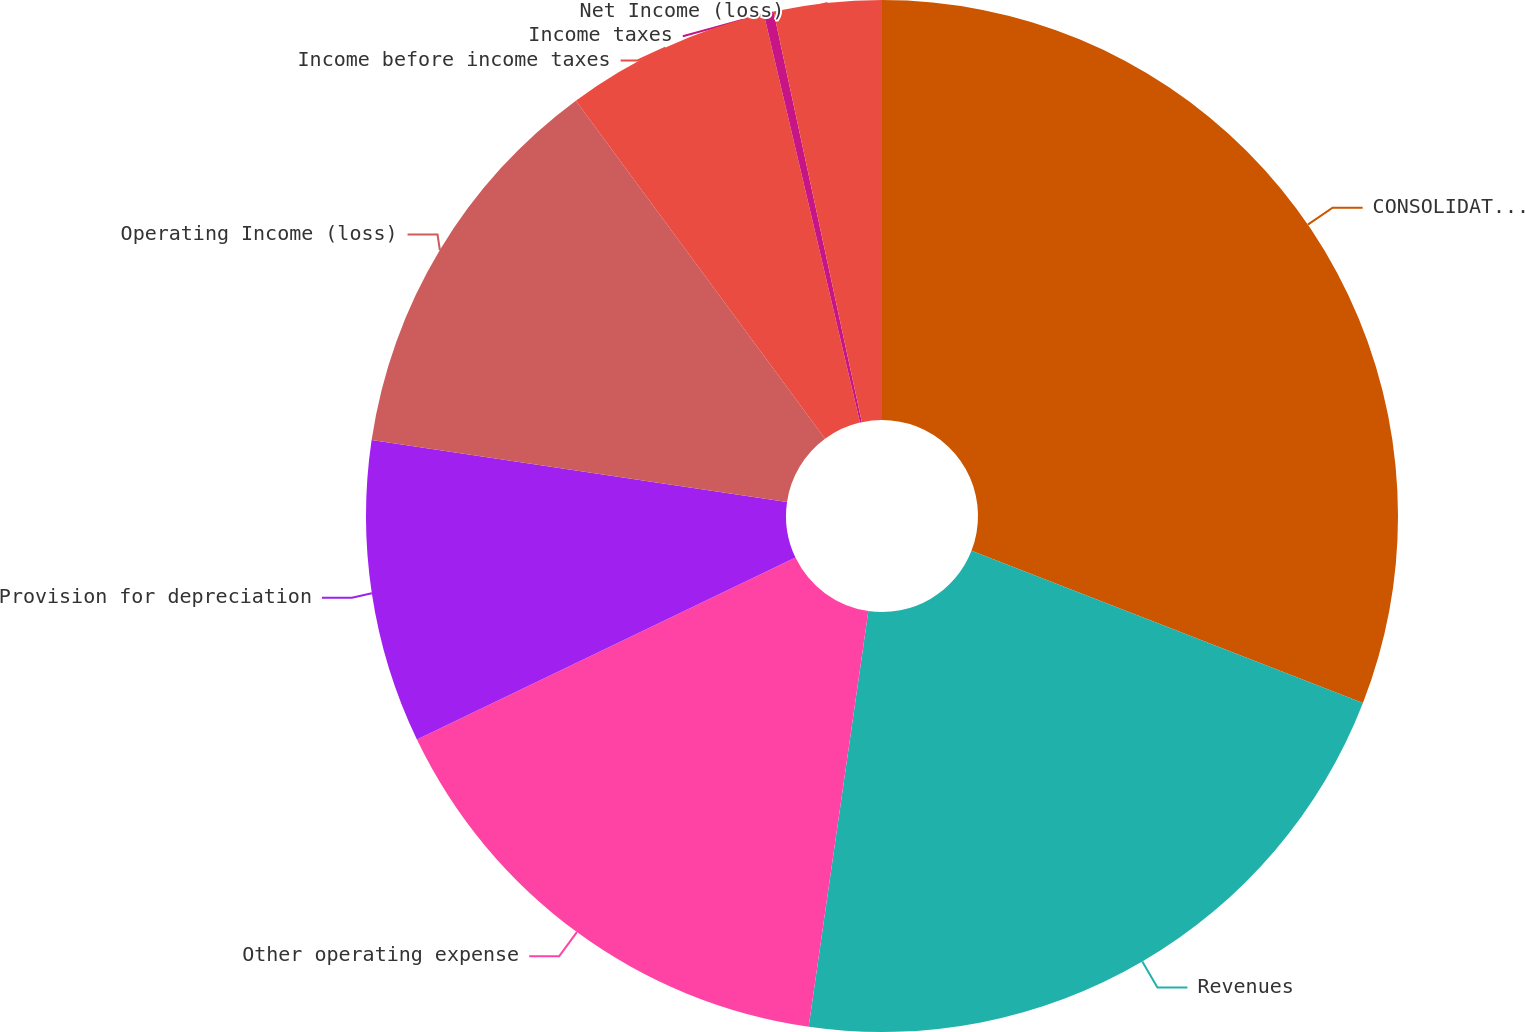Convert chart to OTSL. <chart><loc_0><loc_0><loc_500><loc_500><pie_chart><fcel>CONSOLIDATED STATEMENTS OF<fcel>Revenues<fcel>Other operating expense<fcel>Provision for depreciation<fcel>Operating Income (loss)<fcel>Income before income taxes<fcel>Income taxes<fcel>Net Income (loss)<nl><fcel>30.9%<fcel>21.37%<fcel>15.6%<fcel>9.48%<fcel>12.54%<fcel>6.43%<fcel>0.31%<fcel>3.37%<nl></chart> 